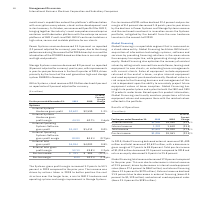According to International Business Machines's financial document, What caused the increase in the Systems gross profit margin? The increase was driven by actions taken in 2018 to better position the cost structure over the longer term, a mix to IBM Z hardware and operating systems and margin improvement in Storage Systems.. The document states: "o 53.1 percent in 2019 compared to the prior year. The increase was driven by actions taken in 2018 to better position the cost structure over the lon..." Also, What caused the decrease in the Pre-tax income? driven by the declines in Power Systems and Storage Systems revenue and the continued investment in innovation across the Systems portfolio, mitigated by the benefit from the new hardware launches in the second-half 2019.. The document states: "n of 8.4 percent decreased 1.8 points year to year driven by the declines in Power Systems and Storage Systems revenue and the continued investment in..." Also, What was the Pre-tax margin in 2019? According to the financial document, 8.4%. The relevant text states: "Pre-tax margin 8.4% 10.2% (1.8)pts...." Also, can you calculate: What was the average External Systems Hardware gross profit? To answer this question, I need to perform calculations using the financial data. The calculation is: (2,622 + 2,590) / 2, which equals 2606 (in millions). This is based on the information: "External Systems Hardware gross profit $2,622 $2,590 1.2% External Systems Hardware gross profit $2,622 $2,590 1.2%..." The key data points involved are: 2,590, 2,622. Also, can you calculate: What is the increase / (decrease) in the External Operating Systems Software gross profit from 2018 to 2019? I cannot find a specific answer to this question in the financial document. Also, can you calculate: What is the average Pre-tax income? To answer this question, I need to perform calculations using the financial data. The calculation is: (701 + 904) / 2, which equals 802.5 (in millions). This is based on the information: "Pre-tax income $ 701 $ 904 (22.4)% Pre-tax income $ 701 $ 904 (22.4)%..." The key data points involved are: 701, 904. 